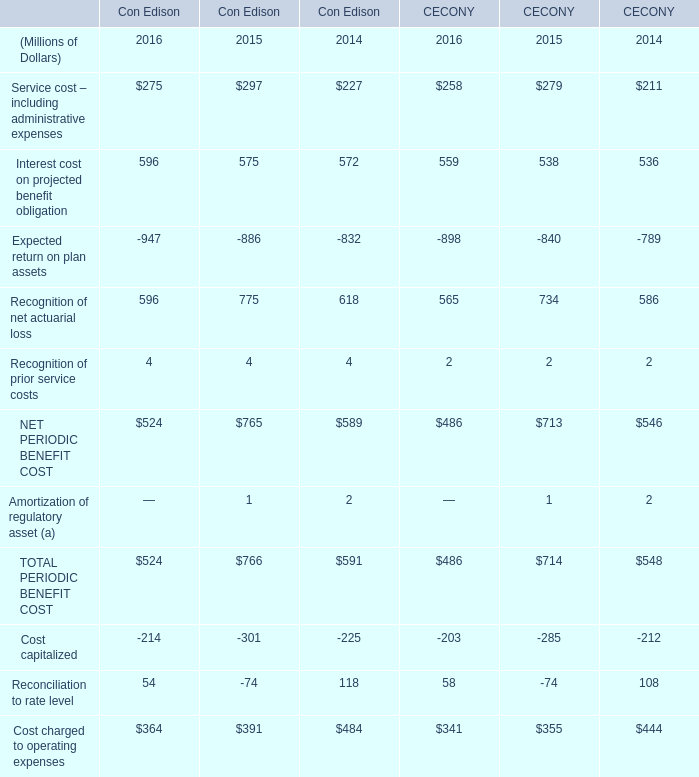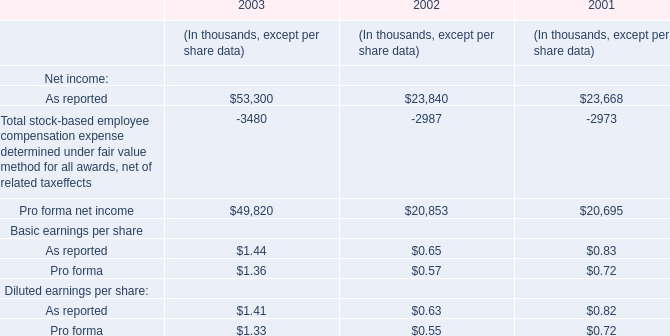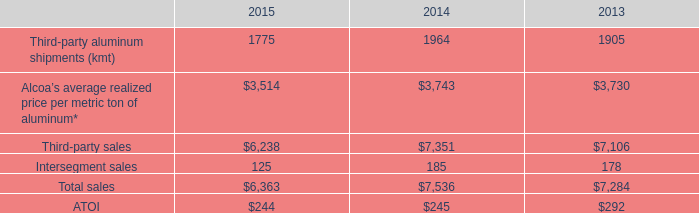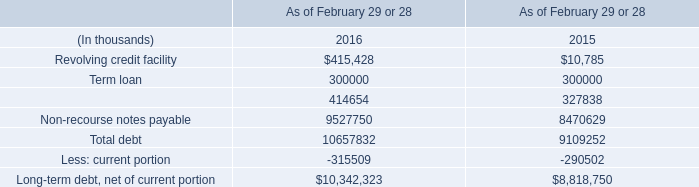What's the sum of the Recognition of net actuarial loss for Con Edison in the years where Finance and capital lease obligations is positive? (in million) 
Computations: (596 + 775)
Answer: 1371.0. 